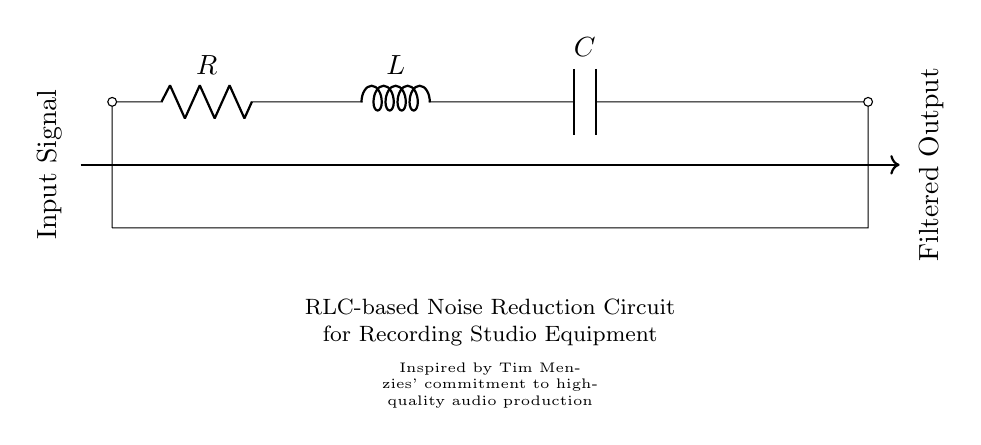What components are in this circuit? The circuit consists of a resistor, inductor, and capacitor, which are labeled as R, L, and C respectively.
Answer: Resistor, Inductor, Capacitor What is the purpose of this circuit? The circuit is designed for noise reduction in recording studio equipment, which is indicated by the label in the diagram.
Answer: Noise reduction What type of circuit is this? This is an RLC circuit, which is categorized based on the presence of a resistor, inductor, and capacitor.
Answer: RLC circuit What does the arrow indicate in the diagram? The arrow indicates the direction of the input signal entering the circuit, showcasing how the signal will flow through the components.
Answer: Input signal direction What happens to the signal after passing through the circuit? The filtered output will be produced as the signal exits the circuit, which is also indicated by the label at the output side.
Answer: Filtered output How many components are connected in series in this circuit? There are three components, the resistor, inductor, and capacitor, connected in series as they are arranged one after another along the same path.
Answer: Three What is the main application of utilizing this RLC circuit? The main application is to improve audio quality by reducing unwanted noise, which is crucial in recording environments.
Answer: Improve audio quality 